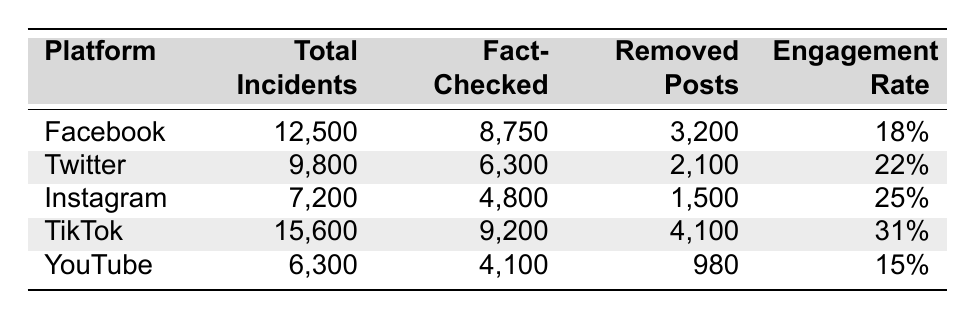What is the total number of incidents reported on TikTok? The table shows that the total incidents reported on TikTok is listed under the "Total Incidents" column. Looking at the TikTok row, it states 15,600 incidents.
Answer: 15,600 Which platform had the highest engagement rate? By comparing the "Engagement Rate" column for each platform, TikTok has the highest figure at 31%, which is greater than the engagement rates of Facebook, Twitter, Instagram, and YouTube.
Answer: TikTok How many incidents were fact-checked on Facebook? The table indicates that the number of incidents fact-checked on Facebook is found in the "Fact-Checked" column under the Facebook row, which shows a value of 8,750.
Answer: 8,750 What is the difference in the total number of incidents between Facebook and YouTube? To find the difference, subtract the total incidents for YouTube (6,300) from Facebook (12,500). The calculation is 12,500 - 6,300 = 6,200.
Answer: 6,200 How many total incidents were reported across all platforms? Add the total incidents for each platform: 12,500 (Facebook) + 9,800 (Twitter) + 7,200 (Instagram) + 15,600 (TikTok) + 6,300 (YouTube). The total is 12,500 + 9,800 + 7,200 + 15,600 + 6,300 = 51,400.
Answer: 51,400 Was the number of removed posts on Instagram higher than on YouTube? The table shows that Instagram had 1,500 removed posts and YouTube had 980. Since 1,500 is greater than 980, the statement is true.
Answer: Yes What percentage of total incidents on Twitter were fact-checked? To calculate this percentage, divide the number of fact-checked incidents on Twitter (6,300) by the total incidents (9,800) and multiply by 100: (6,300 / 9,800) * 100 = 64.29%.
Answer: 64.29% Which platform had the lowest total incidents? By examining the "Total Incidents" column, YouTube has the lowest figure at 6,300 compared to the other platforms listed.
Answer: YouTube What percentage of incidents were removed on TikTok? The number of removed posts on TikTok is 4,100 out of a total of 15,600 incidents. To find the percentage, calculate (4,100 / 15,600) * 100 = 26.28%.
Answer: 26.28% What is the average engagement rate across all platforms? To find the average engagement rate, sum the rates: 18% (Facebook) + 22% (Twitter) + 25% (Instagram) + 31% (TikTok) + 15% (YouTube) = 111%. Then divide by 5 platforms to get 111 / 5 = 22.2%.
Answer: 22.2% Is the number of fact-checked incidents on TikTok greater than the total incidents on Instagram? Checking the data: TikTok has 9,200 fact-checked incidents, while Instagram has 7,200 total incidents. Since 9,200 is greater than 7,200, the statement is true.
Answer: Yes 